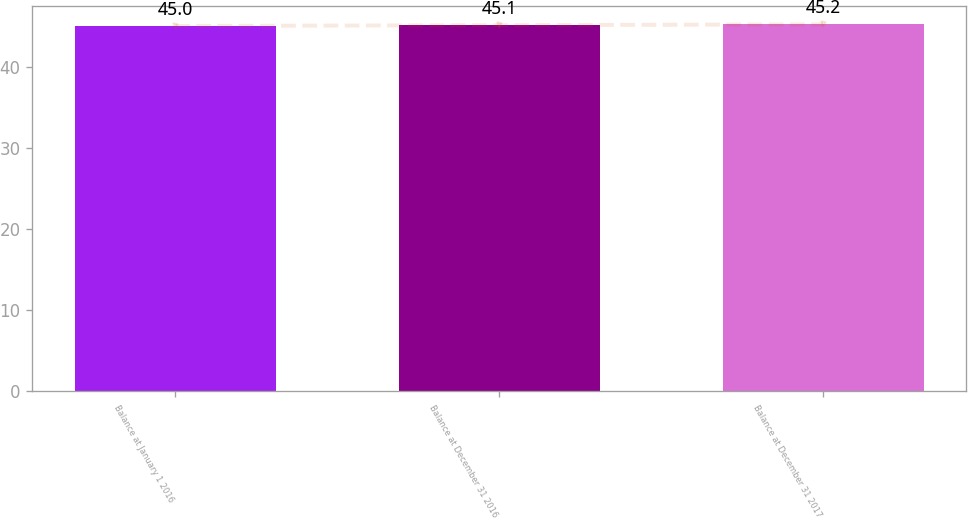<chart> <loc_0><loc_0><loc_500><loc_500><bar_chart><fcel>Balance at January 1 2016<fcel>Balance at December 31 2016<fcel>Balance at December 31 2017<nl><fcel>45<fcel>45.1<fcel>45.2<nl></chart> 